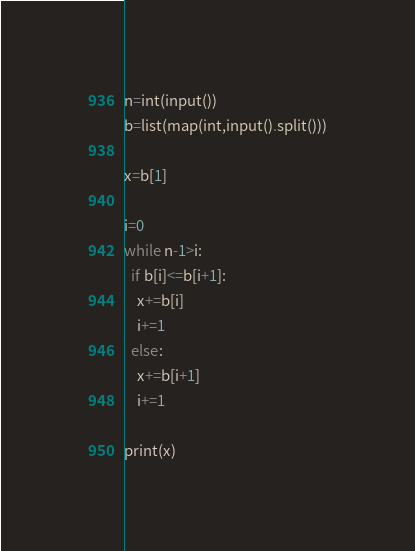<code> <loc_0><loc_0><loc_500><loc_500><_Python_>n=int(input())
b=list(map(int,input().split()))

x=b[1]

i=0
while n-1>i:
  if b[i]<=b[i+1]:
    x+=b[i]
    i+=1
  else:
    x+=b[i+1]
    i+=1
    
print(x)</code> 